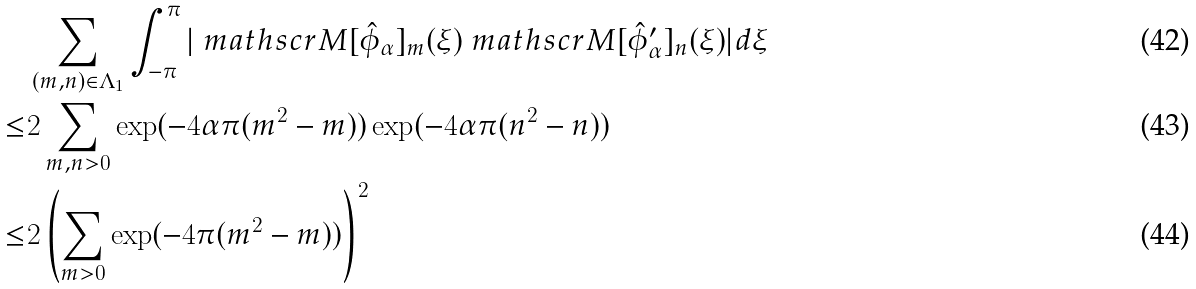<formula> <loc_0><loc_0><loc_500><loc_500>& \sum _ { ( m , n ) \in \Lambda _ { 1 } } \int _ { - \pi } ^ { \pi } | \ m a t h s c r { M } [ \hat { \phi } _ { \alpha } ] _ { m } ( \xi ) \ m a t h s c r { M } [ \hat { \phi } ^ { \prime } _ { \alpha } ] _ { n } ( \xi ) | d \xi \\ \leq & 2 \sum _ { m , n > 0 } \exp ( - 4 \alpha \pi ( m ^ { 2 } - m ) ) \exp ( - 4 \alpha \pi ( n ^ { 2 } - n ) ) \\ \leq & 2 \left ( \sum _ { m > 0 } \exp ( - 4 \pi ( m ^ { 2 } - m ) ) \right ) ^ { 2 }</formula> 